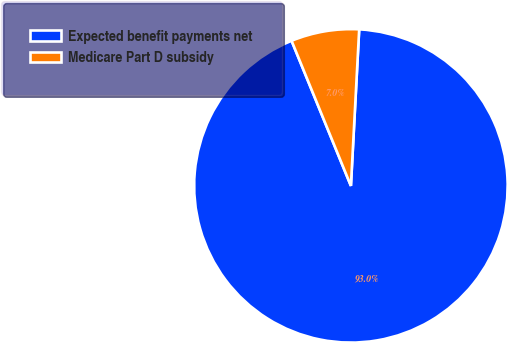<chart> <loc_0><loc_0><loc_500><loc_500><pie_chart><fcel>Expected benefit payments net<fcel>Medicare Part D subsidy<nl><fcel>92.98%<fcel>7.02%<nl></chart> 